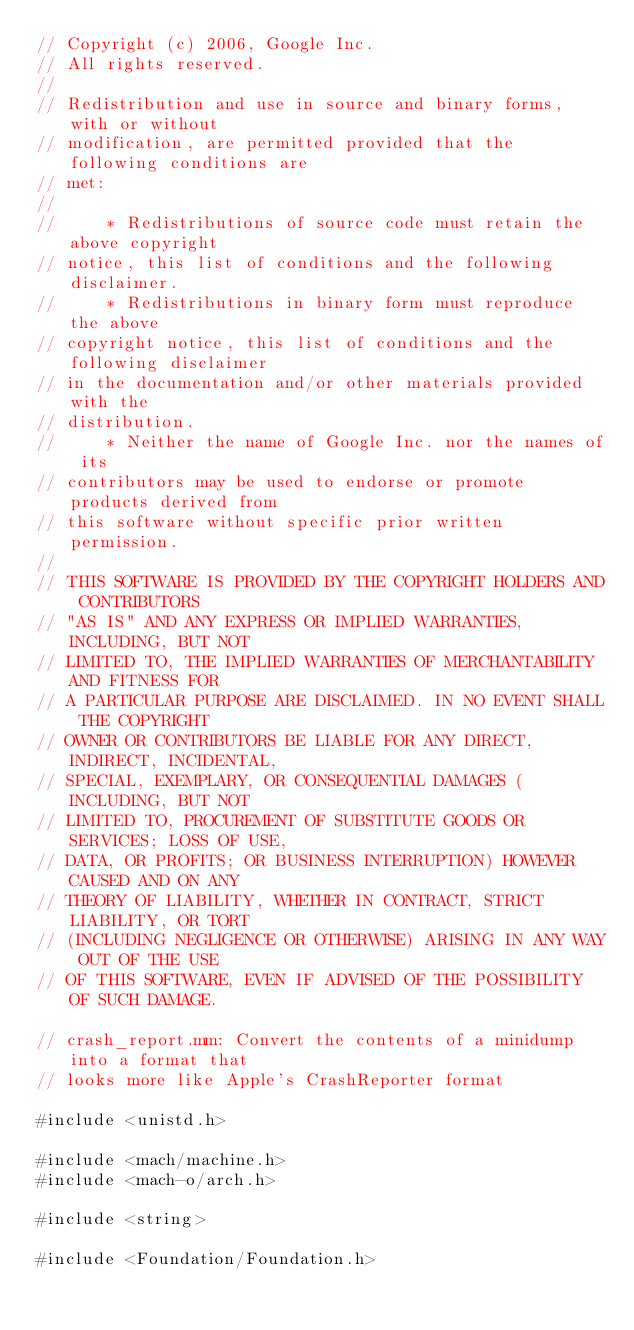Convert code to text. <code><loc_0><loc_0><loc_500><loc_500><_ObjectiveC_>// Copyright (c) 2006, Google Inc.
// All rights reserved.
//
// Redistribution and use in source and binary forms, with or without
// modification, are permitted provided that the following conditions are
// met:
//
//     * Redistributions of source code must retain the above copyright
// notice, this list of conditions and the following disclaimer.
//     * Redistributions in binary form must reproduce the above
// copyright notice, this list of conditions and the following disclaimer
// in the documentation and/or other materials provided with the
// distribution.
//     * Neither the name of Google Inc. nor the names of its
// contributors may be used to endorse or promote products derived from
// this software without specific prior written permission.
//
// THIS SOFTWARE IS PROVIDED BY THE COPYRIGHT HOLDERS AND CONTRIBUTORS
// "AS IS" AND ANY EXPRESS OR IMPLIED WARRANTIES, INCLUDING, BUT NOT
// LIMITED TO, THE IMPLIED WARRANTIES OF MERCHANTABILITY AND FITNESS FOR
// A PARTICULAR PURPOSE ARE DISCLAIMED. IN NO EVENT SHALL THE COPYRIGHT
// OWNER OR CONTRIBUTORS BE LIABLE FOR ANY DIRECT, INDIRECT, INCIDENTAL,
// SPECIAL, EXEMPLARY, OR CONSEQUENTIAL DAMAGES (INCLUDING, BUT NOT
// LIMITED TO, PROCUREMENT OF SUBSTITUTE GOODS OR SERVICES; LOSS OF USE,
// DATA, OR PROFITS; OR BUSINESS INTERRUPTION) HOWEVER CAUSED AND ON ANY
// THEORY OF LIABILITY, WHETHER IN CONTRACT, STRICT LIABILITY, OR TORT
// (INCLUDING NEGLIGENCE OR OTHERWISE) ARISING IN ANY WAY OUT OF THE USE
// OF THIS SOFTWARE, EVEN IF ADVISED OF THE POSSIBILITY OF SUCH DAMAGE.

// crash_report.mm: Convert the contents of a minidump into a format that
// looks more like Apple's CrashReporter format

#include <unistd.h>

#include <mach/machine.h>
#include <mach-o/arch.h>

#include <string>

#include <Foundation/Foundation.h>
</code> 